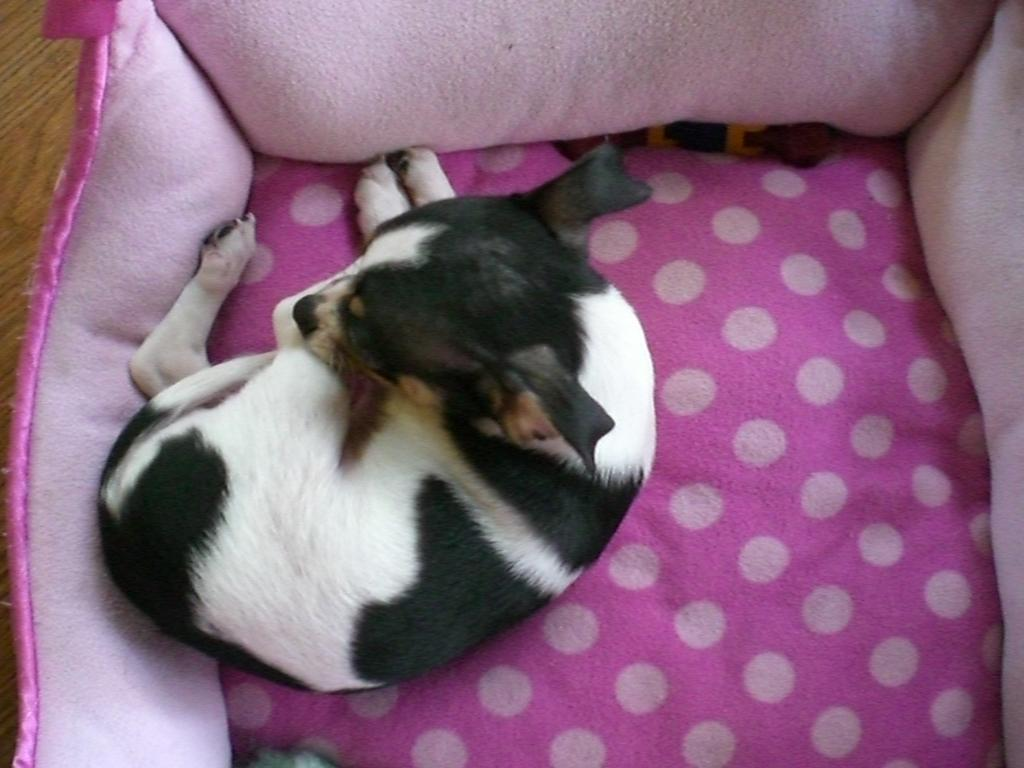What type of animal is in the image? There is a dog in the image. Where is the dog located? The dog is sitting on a sofa chair. Can you describe the dog's color pattern? The dog has a white and black color pattern. What color is the sofa chair? The sofa chair is pink. What type of wire is holding the dog up on the sofa chair? There is no wire present in the image; the dog is sitting on the sofa chair without any visible support. 